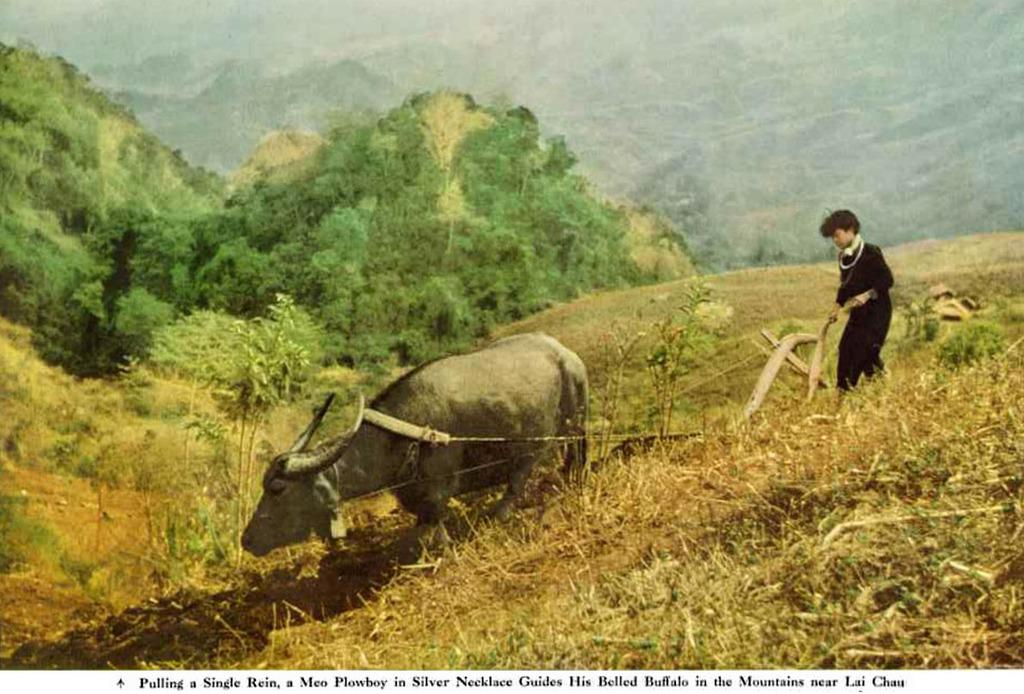What is the person in the image doing? The person is walking in the image. What is the person wearing? The person is wearing clothes. What type of living creature is also present in the image? There is an animal in the image. What type of natural environment can be seen in the image? There is grass, trees, and soil present in the image. What kind of object made of wood can be seen in the image? There is a wooden object in the image. What type of pies can be seen in the image? There are no pies present in the image. What is the level of pollution in the image? The level of pollution cannot be determined from the image, as there is no information provided about pollution. 